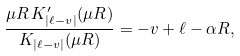Convert formula to latex. <formula><loc_0><loc_0><loc_500><loc_500>\frac { \mu R \, K ^ { \prime } _ { | \ell - v | } ( \mu R ) } { K _ { | \ell - v | } ( \mu R ) } = - v + \ell - \alpha R ,</formula> 